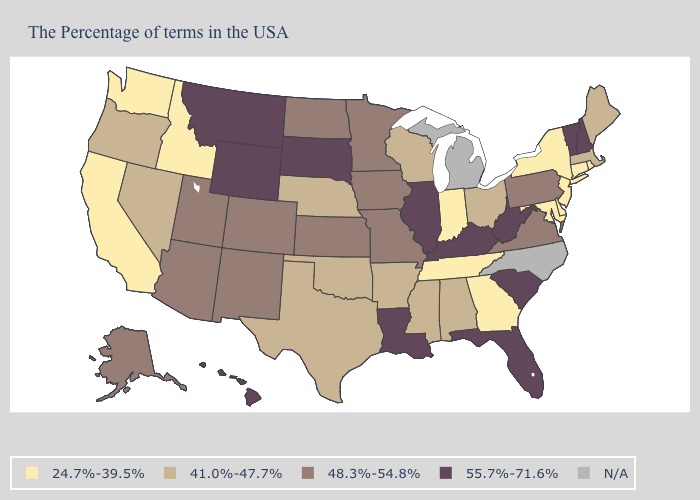Name the states that have a value in the range 41.0%-47.7%?
Be succinct. Maine, Massachusetts, Ohio, Alabama, Wisconsin, Mississippi, Arkansas, Nebraska, Oklahoma, Texas, Nevada, Oregon. What is the lowest value in states that border Washington?
Short answer required. 24.7%-39.5%. Which states have the highest value in the USA?
Write a very short answer. New Hampshire, Vermont, South Carolina, West Virginia, Florida, Kentucky, Illinois, Louisiana, South Dakota, Wyoming, Montana, Hawaii. Is the legend a continuous bar?
Keep it brief. No. Among the states that border North Carolina , does South Carolina have the highest value?
Quick response, please. Yes. Which states have the lowest value in the USA?
Quick response, please. Rhode Island, Connecticut, New York, New Jersey, Delaware, Maryland, Georgia, Indiana, Tennessee, Idaho, California, Washington. What is the highest value in states that border Oregon?
Keep it brief. 41.0%-47.7%. What is the lowest value in the USA?
Write a very short answer. 24.7%-39.5%. Which states have the lowest value in the Northeast?
Answer briefly. Rhode Island, Connecticut, New York, New Jersey. How many symbols are there in the legend?
Quick response, please. 5. What is the lowest value in the USA?
Answer briefly. 24.7%-39.5%. Among the states that border Minnesota , does South Dakota have the highest value?
Answer briefly. Yes. Name the states that have a value in the range 24.7%-39.5%?
Short answer required. Rhode Island, Connecticut, New York, New Jersey, Delaware, Maryland, Georgia, Indiana, Tennessee, Idaho, California, Washington. What is the lowest value in the USA?
Short answer required. 24.7%-39.5%. 